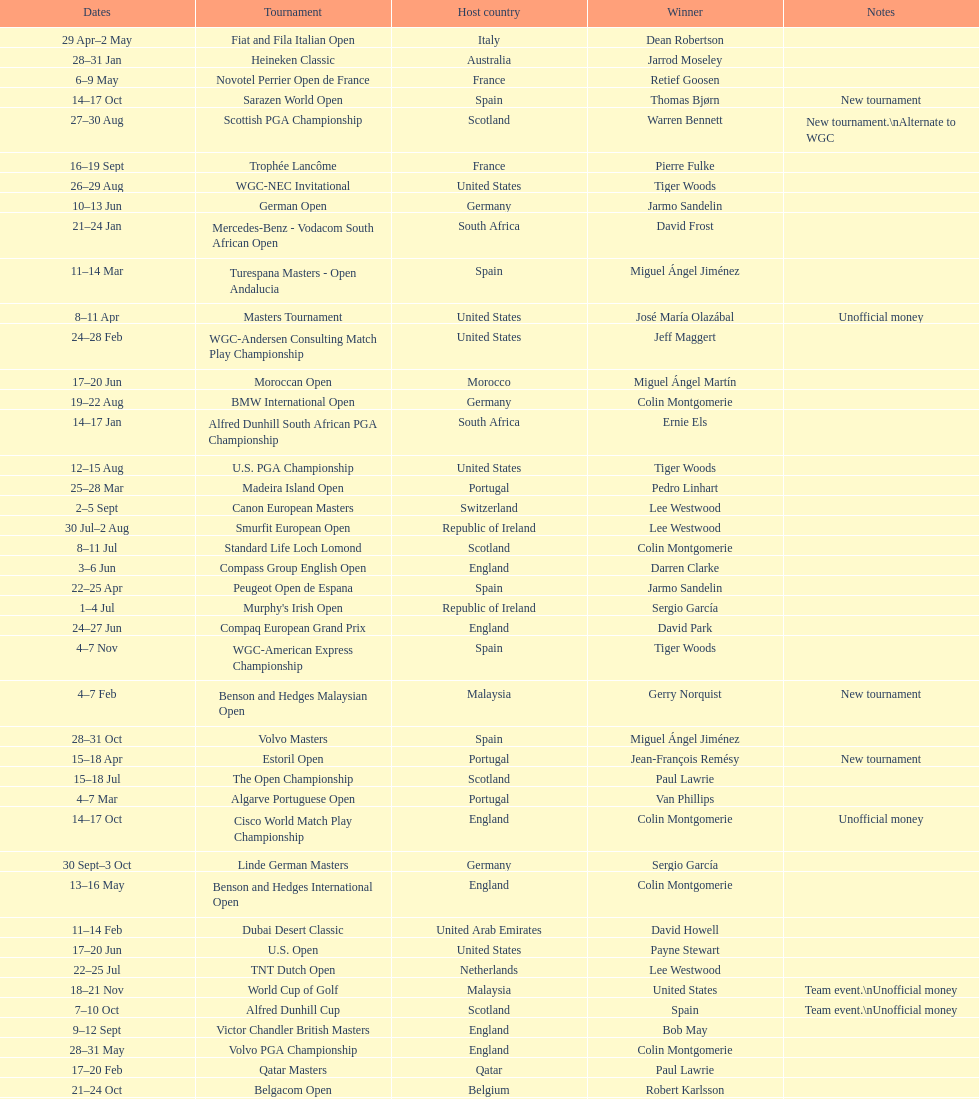Other than qatar masters, name a tournament that was in february. Dubai Desert Classic. 